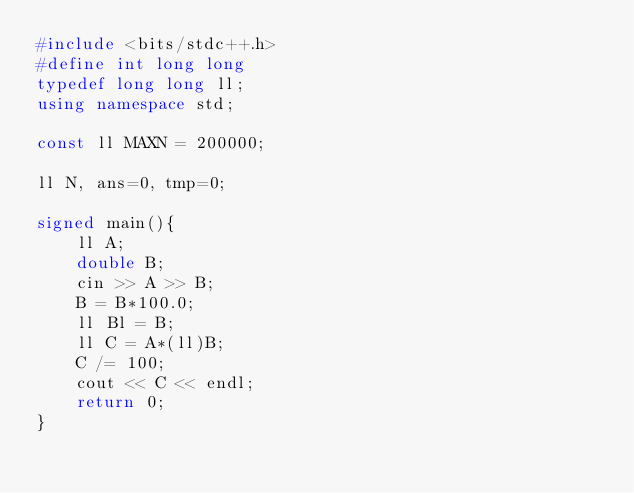<code> <loc_0><loc_0><loc_500><loc_500><_C++_>#include <bits/stdc++.h>
#define int long long
typedef long long ll;
using namespace std;

const ll MAXN = 200000;

ll N, ans=0, tmp=0;

signed main(){
    ll A;
    double B;
    cin >> A >> B;
    B = B*100.0;
    ll Bl = B;
    ll C = A*(ll)B;
    C /= 100;
    cout << C << endl;
    return 0;
}</code> 